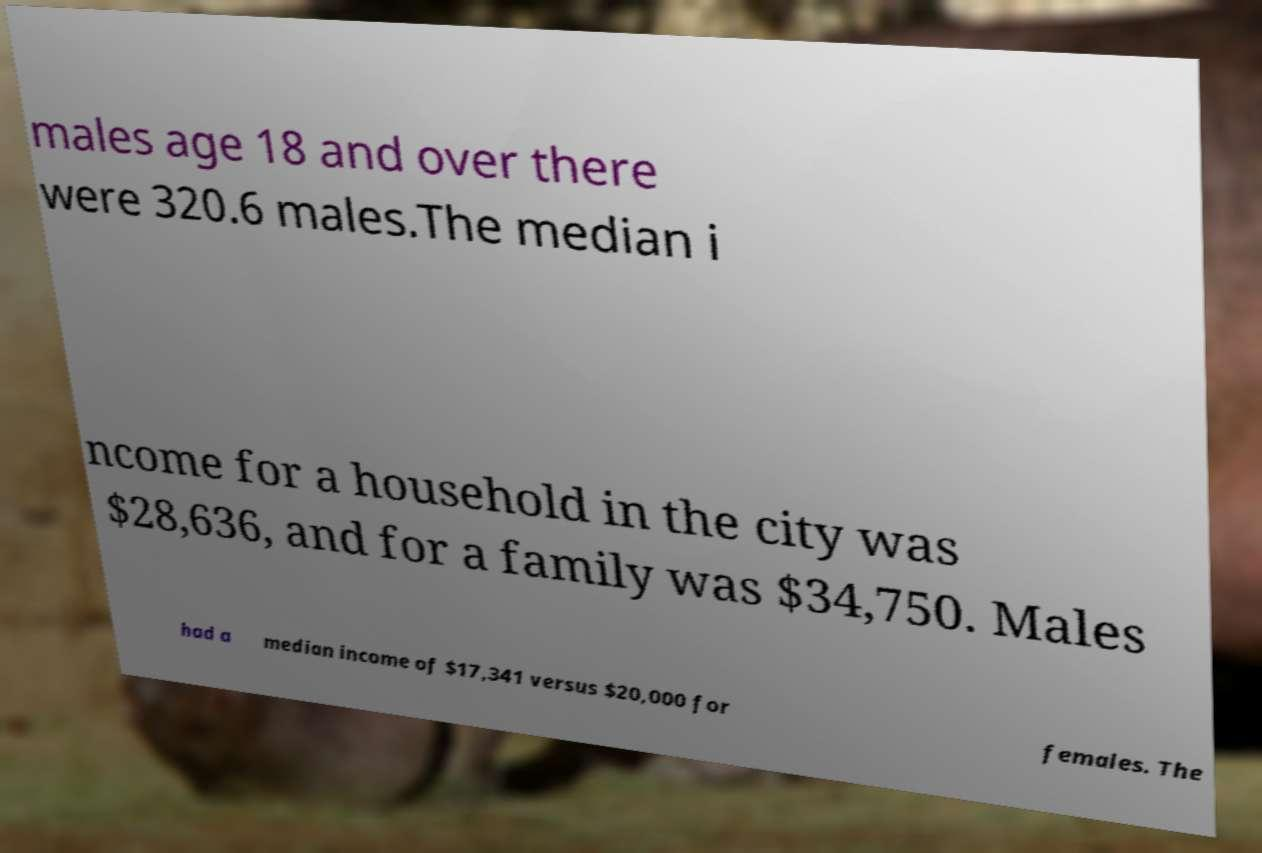There's text embedded in this image that I need extracted. Can you transcribe it verbatim? males age 18 and over there were 320.6 males.The median i ncome for a household in the city was $28,636, and for a family was $34,750. Males had a median income of $17,341 versus $20,000 for females. The 